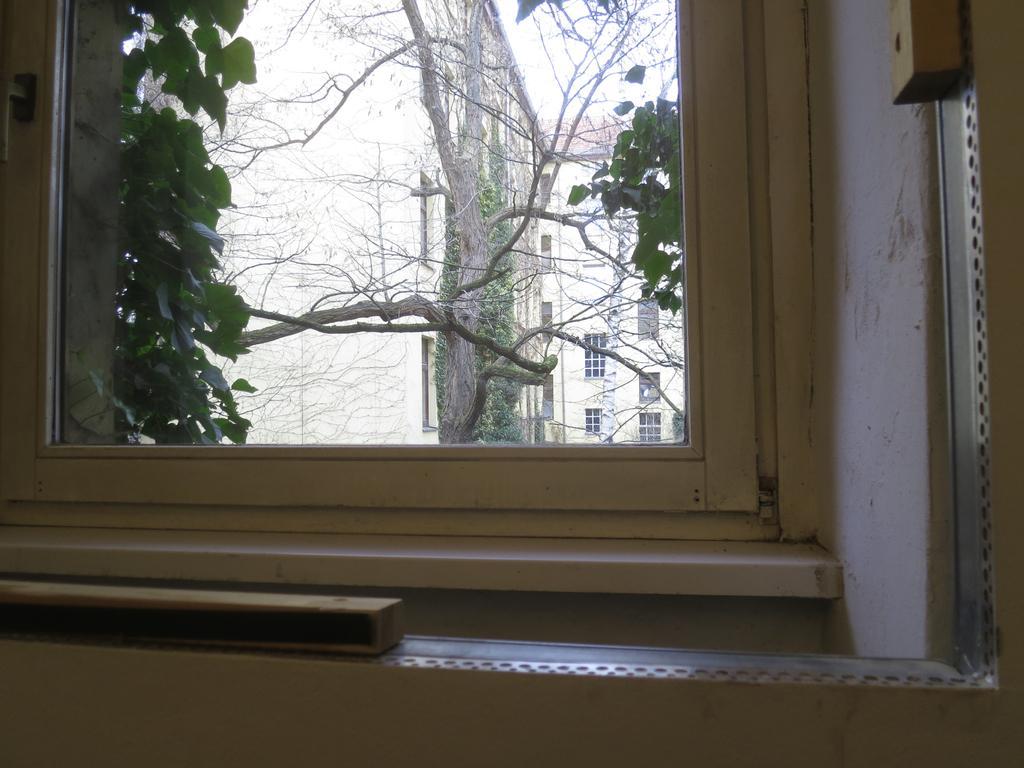How would you summarize this image in a sentence or two? In this picture we can see a window, some objects and trees. In the background we can see buildings with windows and the sky. 